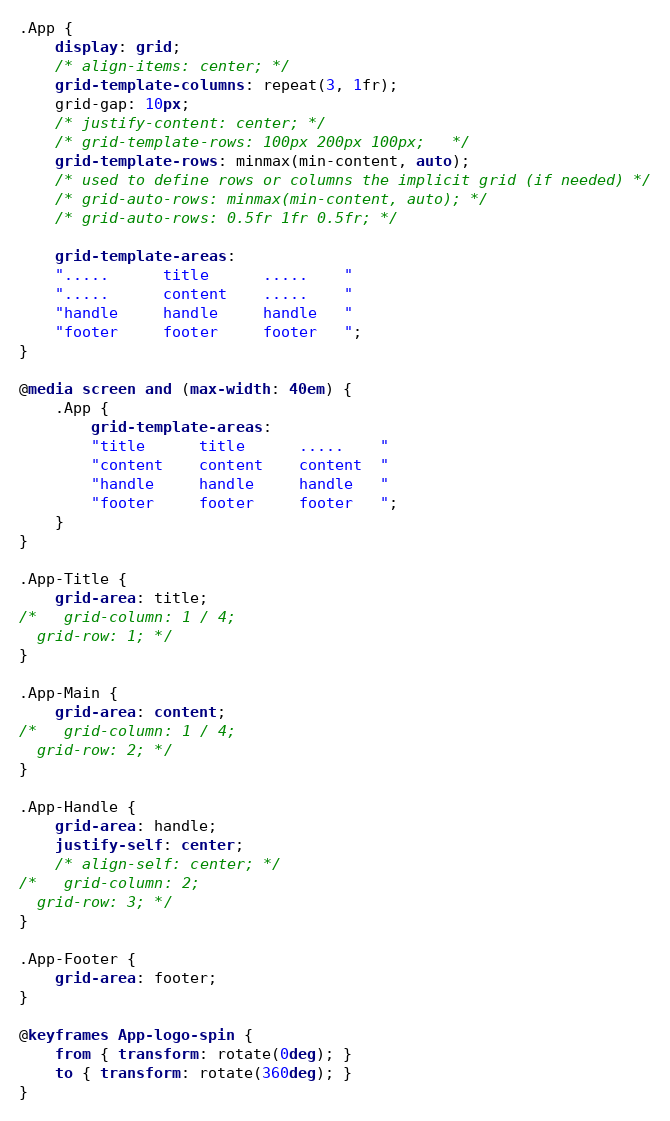<code> <loc_0><loc_0><loc_500><loc_500><_CSS_>.App {
    display: grid;
    /* align-items: center; */
    grid-template-columns: repeat(3, 1fr);
    grid-gap: 10px;
    /* justify-content: center; */
    /* grid-template-rows: 100px 200px 100px;   */
    grid-template-rows: minmax(min-content, auto);
    /* used to define rows or columns the implicit grid (if needed) */
    /* grid-auto-rows: minmax(min-content, auto); */
    /* grid-auto-rows: 0.5fr 1fr 0.5fr; */
    
    grid-template-areas:
    ".....      title      .....    "
    ".....      content    .....    "
    "handle     handle     handle   "
    "footer     footer     footer   ";
}

@media screen and (max-width: 40em) {
    .App {
        grid-template-areas:
        "title      title      .....    "
        "content    content    content  "
        "handle     handle     handle   "
        "footer     footer     footer   ";
    }
}

.App-Title {
    grid-area: title;
/*   grid-column: 1 / 4;
  grid-row: 1; */
}

.App-Main {
    grid-area: content;
/*   grid-column: 1 / 4;
  grid-row: 2; */
}

.App-Handle {
    grid-area: handle;
    justify-self: center;
    /* align-self: center; */
/*   grid-column: 2;
  grid-row: 3; */
}

.App-Footer {
    grid-area: footer;
}

@keyframes App-logo-spin {
    from { transform: rotate(0deg); }
    to { transform: rotate(360deg); }
}
</code> 